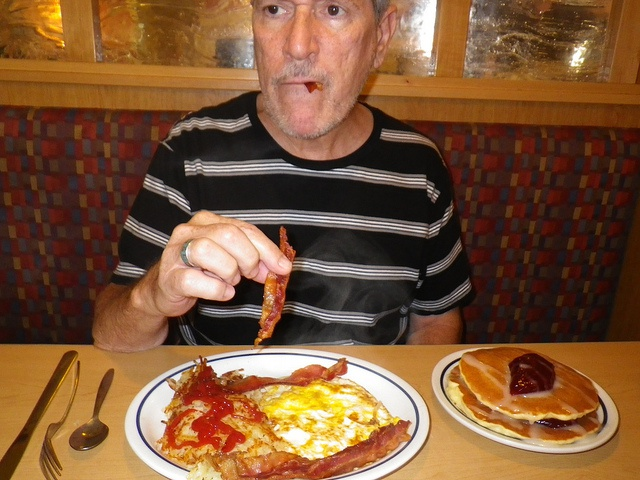Describe the objects in this image and their specific colors. I can see people in maroon, black, salmon, and gray tones, dining table in maroon, olive, and tan tones, pizza in maroon, brown, orange, khaki, and ivory tones, pizza in maroon, brown, tan, and orange tones, and knife in maroon, olive, and black tones in this image. 